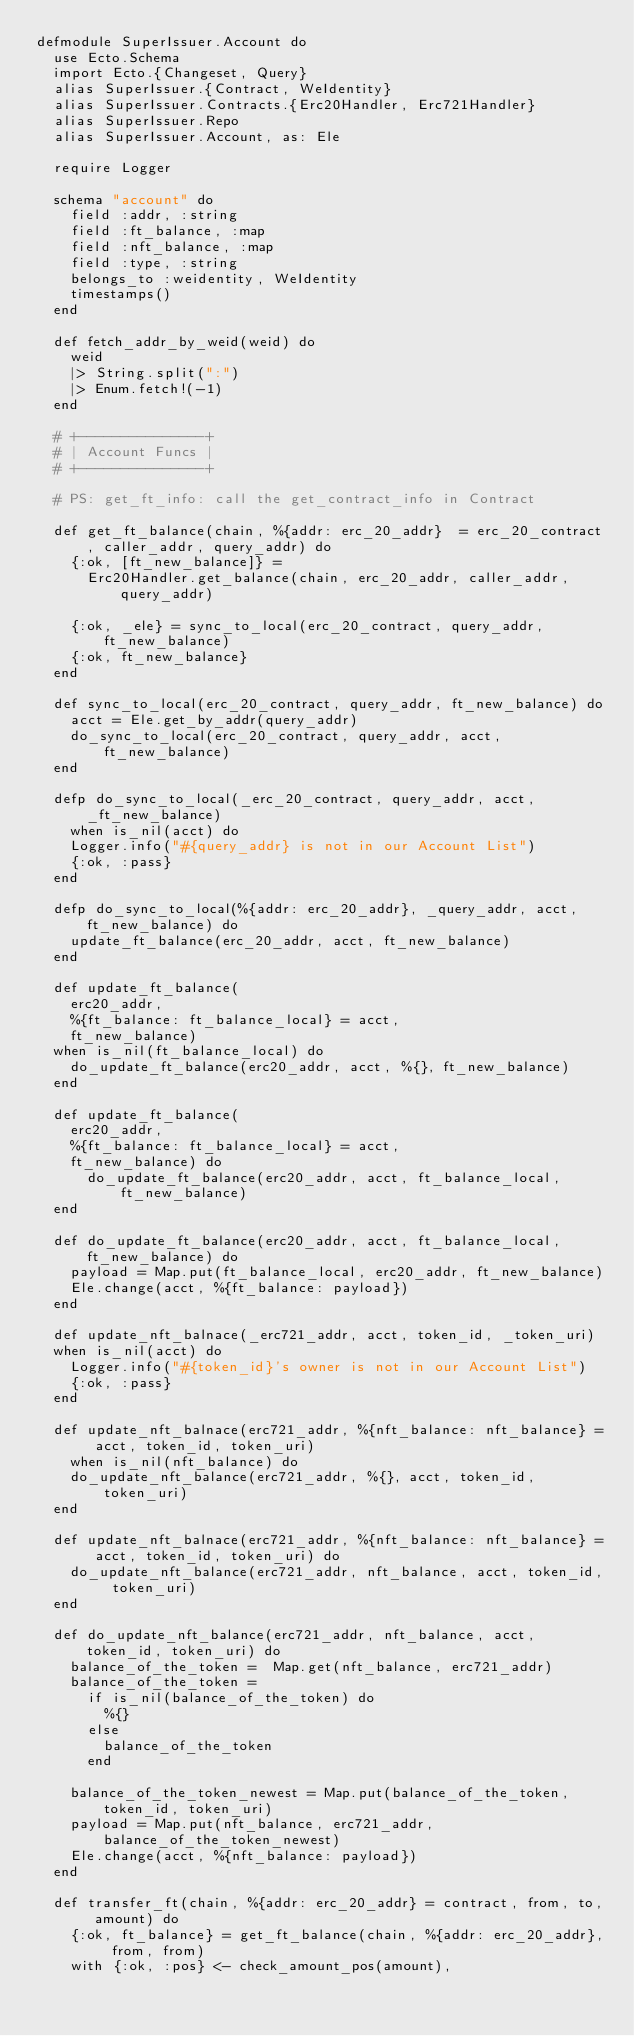<code> <loc_0><loc_0><loc_500><loc_500><_Elixir_>defmodule SuperIssuer.Account do
  use Ecto.Schema
  import Ecto.{Changeset, Query}
  alias SuperIssuer.{Contract, WeIdentity}
  alias SuperIssuer.Contracts.{Erc20Handler, Erc721Handler}
  alias SuperIssuer.Repo
  alias SuperIssuer.Account, as: Ele

  require Logger

  schema "account" do
    field :addr, :string
    field :ft_balance, :map
    field :nft_balance, :map
    field :type, :string
    belongs_to :weidentity, WeIdentity
    timestamps()
  end

  def fetch_addr_by_weid(weid) do
    weid
    |> String.split(":")
    |> Enum.fetch!(-1)
  end

  # +---------------+
  # | Account Funcs |
  # +---------------+

  # PS: get_ft_info: call the get_contract_info in Contract

  def get_ft_balance(chain, %{addr: erc_20_addr}  = erc_20_contract, caller_addr, query_addr) do
    {:ok, [ft_new_balance]} =
      Erc20Handler.get_balance(chain, erc_20_addr, caller_addr, query_addr)

    {:ok, _ele} = sync_to_local(erc_20_contract, query_addr, ft_new_balance)
    {:ok, ft_new_balance}
  end

  def sync_to_local(erc_20_contract, query_addr, ft_new_balance) do
    acct = Ele.get_by_addr(query_addr)
    do_sync_to_local(erc_20_contract, query_addr, acct, ft_new_balance)
  end

  defp do_sync_to_local(_erc_20_contract, query_addr, acct, _ft_new_balance)
    when is_nil(acct) do
    Logger.info("#{query_addr} is not in our Account List")
    {:ok, :pass}
  end

  defp do_sync_to_local(%{addr: erc_20_addr}, _query_addr, acct, ft_new_balance) do
    update_ft_balance(erc_20_addr, acct, ft_new_balance)
  end

  def update_ft_balance(
    erc20_addr,
    %{ft_balance: ft_balance_local} = acct,
    ft_new_balance)
  when is_nil(ft_balance_local) do
    do_update_ft_balance(erc20_addr, acct, %{}, ft_new_balance)
  end

  def update_ft_balance(
    erc20_addr,
    %{ft_balance: ft_balance_local} = acct,
    ft_new_balance) do
      do_update_ft_balance(erc20_addr, acct, ft_balance_local, ft_new_balance)
  end

  def do_update_ft_balance(erc20_addr, acct, ft_balance_local, ft_new_balance) do
    payload = Map.put(ft_balance_local, erc20_addr, ft_new_balance)
    Ele.change(acct, %{ft_balance: payload})
  end

  def update_nft_balnace(_erc721_addr, acct, token_id, _token_uri)
  when is_nil(acct) do
    Logger.info("#{token_id}'s owner is not in our Account List")
    {:ok, :pass}
  end

  def update_nft_balnace(erc721_addr, %{nft_balance: nft_balance} = acct, token_id, token_uri)
    when is_nil(nft_balance) do
    do_update_nft_balance(erc721_addr, %{}, acct, token_id, token_uri)
  end

  def update_nft_balnace(erc721_addr, %{nft_balance: nft_balance} = acct, token_id, token_uri) do
    do_update_nft_balance(erc721_addr, nft_balance, acct, token_id, token_uri)
  end

  def do_update_nft_balance(erc721_addr, nft_balance, acct, token_id, token_uri) do
    balance_of_the_token =  Map.get(nft_balance, erc721_addr)
    balance_of_the_token =
      if is_nil(balance_of_the_token) do
        %{}
      else
        balance_of_the_token
      end

    balance_of_the_token_newest = Map.put(balance_of_the_token,  token_id, token_uri)
    payload = Map.put(nft_balance, erc721_addr, balance_of_the_token_newest)
    Ele.change(acct, %{nft_balance: payload})
  end

  def transfer_ft(chain, %{addr: erc_20_addr} = contract, from, to, amount) do
    {:ok, ft_balance} = get_ft_balance(chain, %{addr: erc_20_addr}, from, from)
    with {:ok, :pos} <- check_amount_pos(amount),</code> 